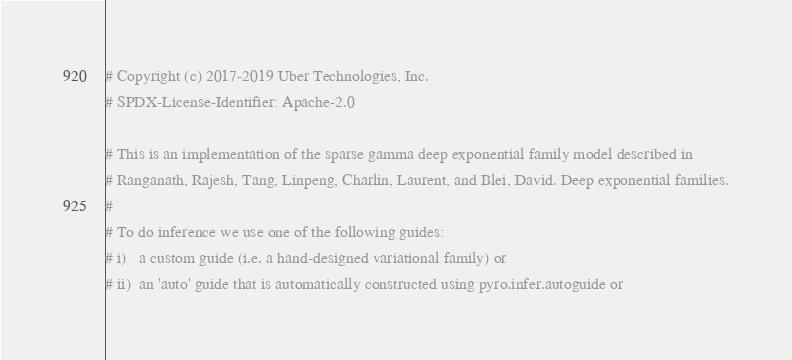Convert code to text. <code><loc_0><loc_0><loc_500><loc_500><_Python_># Copyright (c) 2017-2019 Uber Technologies, Inc.
# SPDX-License-Identifier: Apache-2.0

# This is an implementation of the sparse gamma deep exponential family model described in
# Ranganath, Rajesh, Tang, Linpeng, Charlin, Laurent, and Blei, David. Deep exponential families.
#
# To do inference we use one of the following guides:
# i)   a custom guide (i.e. a hand-designed variational family) or
# ii)  an 'auto' guide that is automatically constructed using pyro.infer.autoguide or</code> 